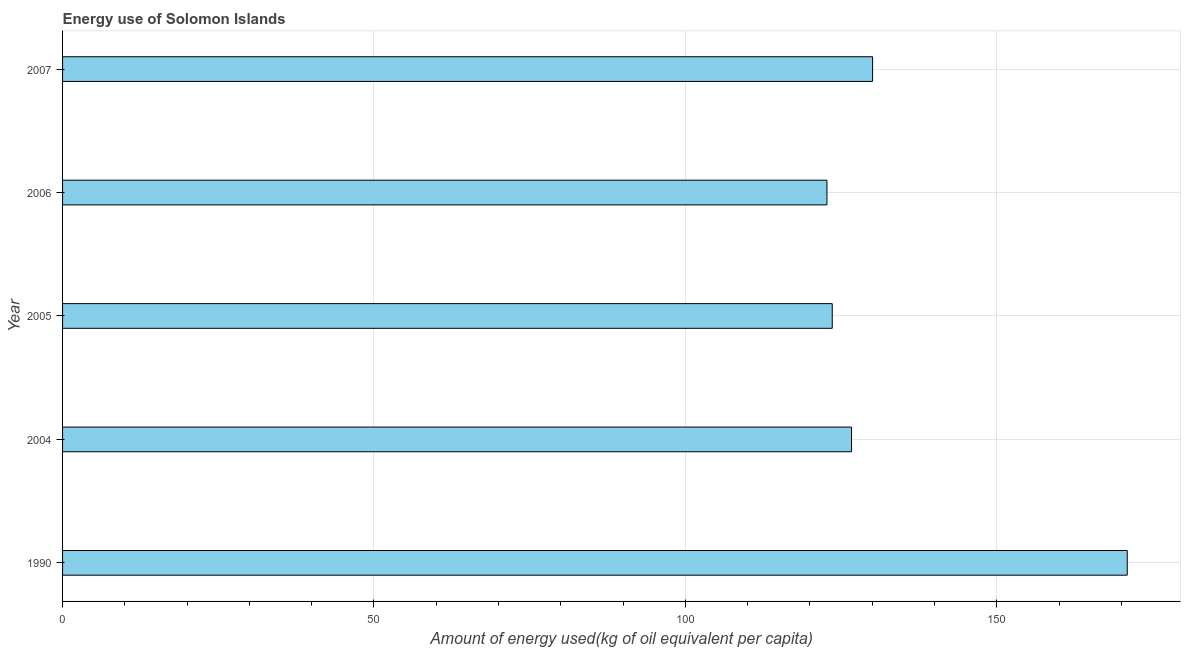What is the title of the graph?
Offer a terse response. Energy use of Solomon Islands. What is the label or title of the X-axis?
Your answer should be very brief. Amount of energy used(kg of oil equivalent per capita). What is the label or title of the Y-axis?
Offer a terse response. Year. What is the amount of energy used in 2006?
Offer a very short reply. 122.73. Across all years, what is the maximum amount of energy used?
Offer a very short reply. 170.95. Across all years, what is the minimum amount of energy used?
Offer a terse response. 122.73. What is the sum of the amount of energy used?
Offer a very short reply. 674.02. What is the difference between the amount of energy used in 1990 and 2005?
Ensure brevity in your answer.  47.37. What is the average amount of energy used per year?
Your answer should be compact. 134.8. What is the median amount of energy used?
Give a very brief answer. 126.68. In how many years, is the amount of energy used greater than 40 kg?
Provide a succinct answer. 5. Do a majority of the years between 1990 and 2005 (inclusive) have amount of energy used greater than 20 kg?
Your answer should be very brief. Yes. What is the ratio of the amount of energy used in 1990 to that in 2007?
Offer a terse response. 1.31. Is the difference between the amount of energy used in 2004 and 2007 greater than the difference between any two years?
Your response must be concise. No. What is the difference between the highest and the second highest amount of energy used?
Your answer should be very brief. 40.89. What is the difference between the highest and the lowest amount of energy used?
Offer a very short reply. 48.22. In how many years, is the amount of energy used greater than the average amount of energy used taken over all years?
Your answer should be compact. 1. Are all the bars in the graph horizontal?
Keep it short and to the point. Yes. Are the values on the major ticks of X-axis written in scientific E-notation?
Make the answer very short. No. What is the Amount of energy used(kg of oil equivalent per capita) in 1990?
Offer a very short reply. 170.95. What is the Amount of energy used(kg of oil equivalent per capita) of 2004?
Ensure brevity in your answer.  126.68. What is the Amount of energy used(kg of oil equivalent per capita) in 2005?
Give a very brief answer. 123.59. What is the Amount of energy used(kg of oil equivalent per capita) of 2006?
Your response must be concise. 122.73. What is the Amount of energy used(kg of oil equivalent per capita) in 2007?
Give a very brief answer. 130.06. What is the difference between the Amount of energy used(kg of oil equivalent per capita) in 1990 and 2004?
Offer a terse response. 44.27. What is the difference between the Amount of energy used(kg of oil equivalent per capita) in 1990 and 2005?
Offer a terse response. 47.37. What is the difference between the Amount of energy used(kg of oil equivalent per capita) in 1990 and 2006?
Your answer should be compact. 48.22. What is the difference between the Amount of energy used(kg of oil equivalent per capita) in 1990 and 2007?
Ensure brevity in your answer.  40.89. What is the difference between the Amount of energy used(kg of oil equivalent per capita) in 2004 and 2005?
Offer a terse response. 3.09. What is the difference between the Amount of energy used(kg of oil equivalent per capita) in 2004 and 2006?
Keep it short and to the point. 3.95. What is the difference between the Amount of energy used(kg of oil equivalent per capita) in 2004 and 2007?
Ensure brevity in your answer.  -3.38. What is the difference between the Amount of energy used(kg of oil equivalent per capita) in 2005 and 2006?
Offer a terse response. 0.85. What is the difference between the Amount of energy used(kg of oil equivalent per capita) in 2005 and 2007?
Your answer should be compact. -6.47. What is the difference between the Amount of energy used(kg of oil equivalent per capita) in 2006 and 2007?
Provide a succinct answer. -7.33. What is the ratio of the Amount of energy used(kg of oil equivalent per capita) in 1990 to that in 2004?
Provide a short and direct response. 1.35. What is the ratio of the Amount of energy used(kg of oil equivalent per capita) in 1990 to that in 2005?
Your answer should be very brief. 1.38. What is the ratio of the Amount of energy used(kg of oil equivalent per capita) in 1990 to that in 2006?
Your answer should be compact. 1.39. What is the ratio of the Amount of energy used(kg of oil equivalent per capita) in 1990 to that in 2007?
Your answer should be very brief. 1.31. What is the ratio of the Amount of energy used(kg of oil equivalent per capita) in 2004 to that in 2006?
Provide a succinct answer. 1.03. What is the ratio of the Amount of energy used(kg of oil equivalent per capita) in 2004 to that in 2007?
Offer a very short reply. 0.97. What is the ratio of the Amount of energy used(kg of oil equivalent per capita) in 2005 to that in 2007?
Provide a short and direct response. 0.95. What is the ratio of the Amount of energy used(kg of oil equivalent per capita) in 2006 to that in 2007?
Make the answer very short. 0.94. 